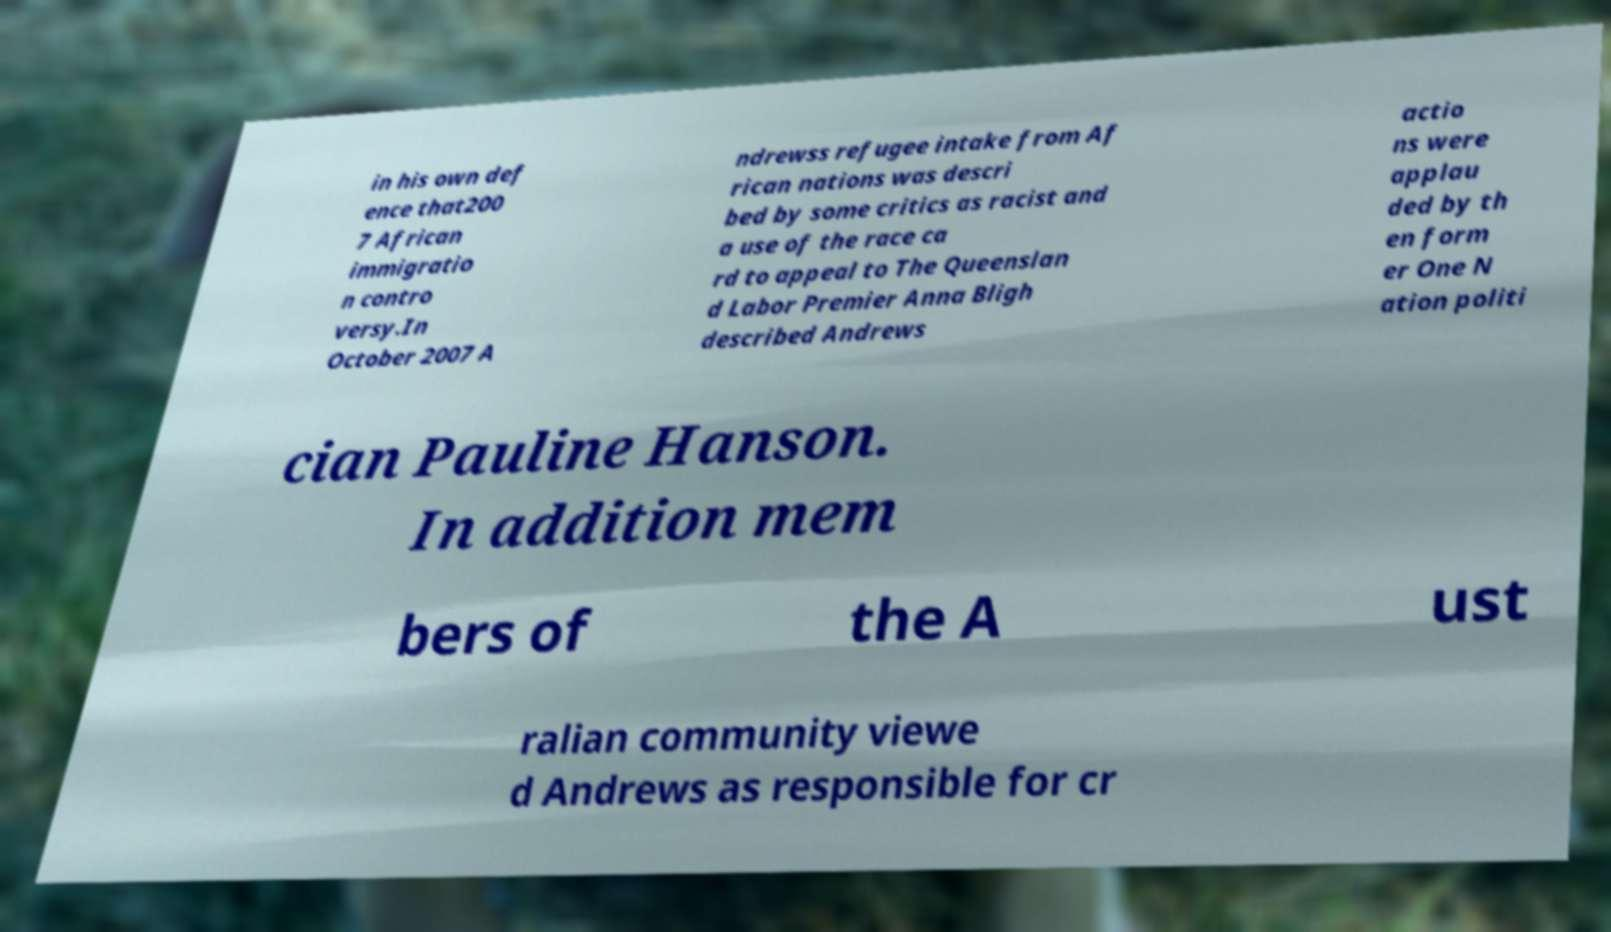Could you assist in decoding the text presented in this image and type it out clearly? in his own def ence that200 7 African immigratio n contro versy.In October 2007 A ndrewss refugee intake from Af rican nations was descri bed by some critics as racist and a use of the race ca rd to appeal to The Queenslan d Labor Premier Anna Bligh described Andrews actio ns were applau ded by th en form er One N ation politi cian Pauline Hanson. In addition mem bers of the A ust ralian community viewe d Andrews as responsible for cr 